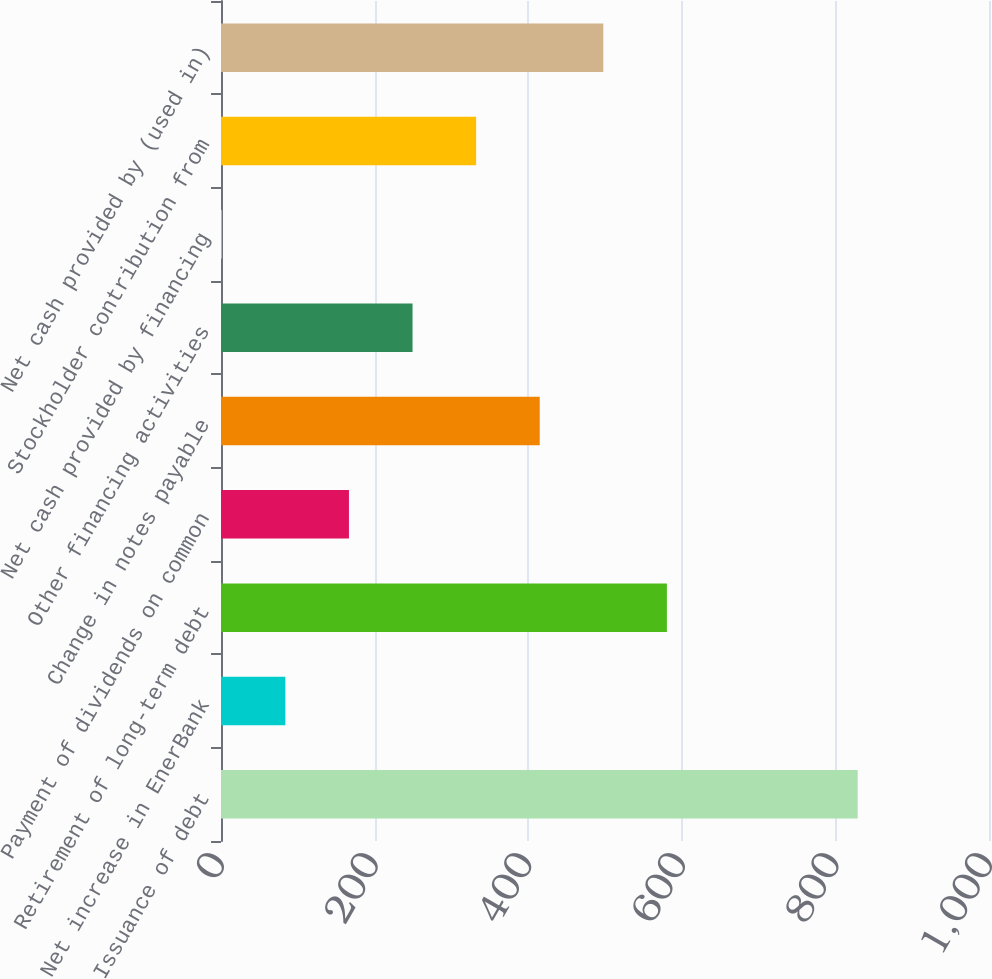<chart> <loc_0><loc_0><loc_500><loc_500><bar_chart><fcel>Issuance of debt<fcel>Net increase in EnerBank<fcel>Retirement of long-term debt<fcel>Payment of dividends on common<fcel>Change in notes payable<fcel>Other financing activities<fcel>Net cash provided by financing<fcel>Stockholder contribution from<fcel>Net cash provided by (used in)<nl><fcel>829<fcel>83.8<fcel>580.6<fcel>166.6<fcel>415<fcel>249.4<fcel>1<fcel>332.2<fcel>497.8<nl></chart> 